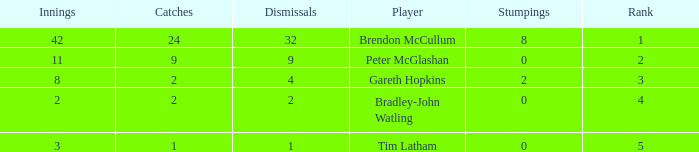List the ranks of all dismissals with a value of 4 3.0. 